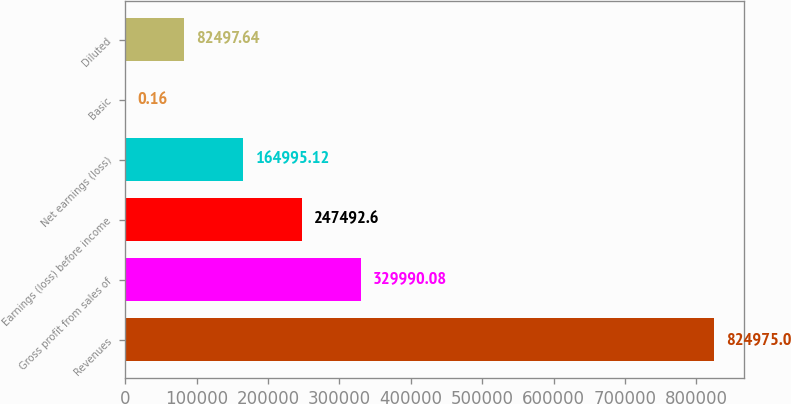<chart> <loc_0><loc_0><loc_500><loc_500><bar_chart><fcel>Revenues<fcel>Gross profit from sales of<fcel>Earnings (loss) before income<fcel>Net earnings (loss)<fcel>Basic<fcel>Diluted<nl><fcel>824975<fcel>329990<fcel>247493<fcel>164995<fcel>0.16<fcel>82497.6<nl></chart> 